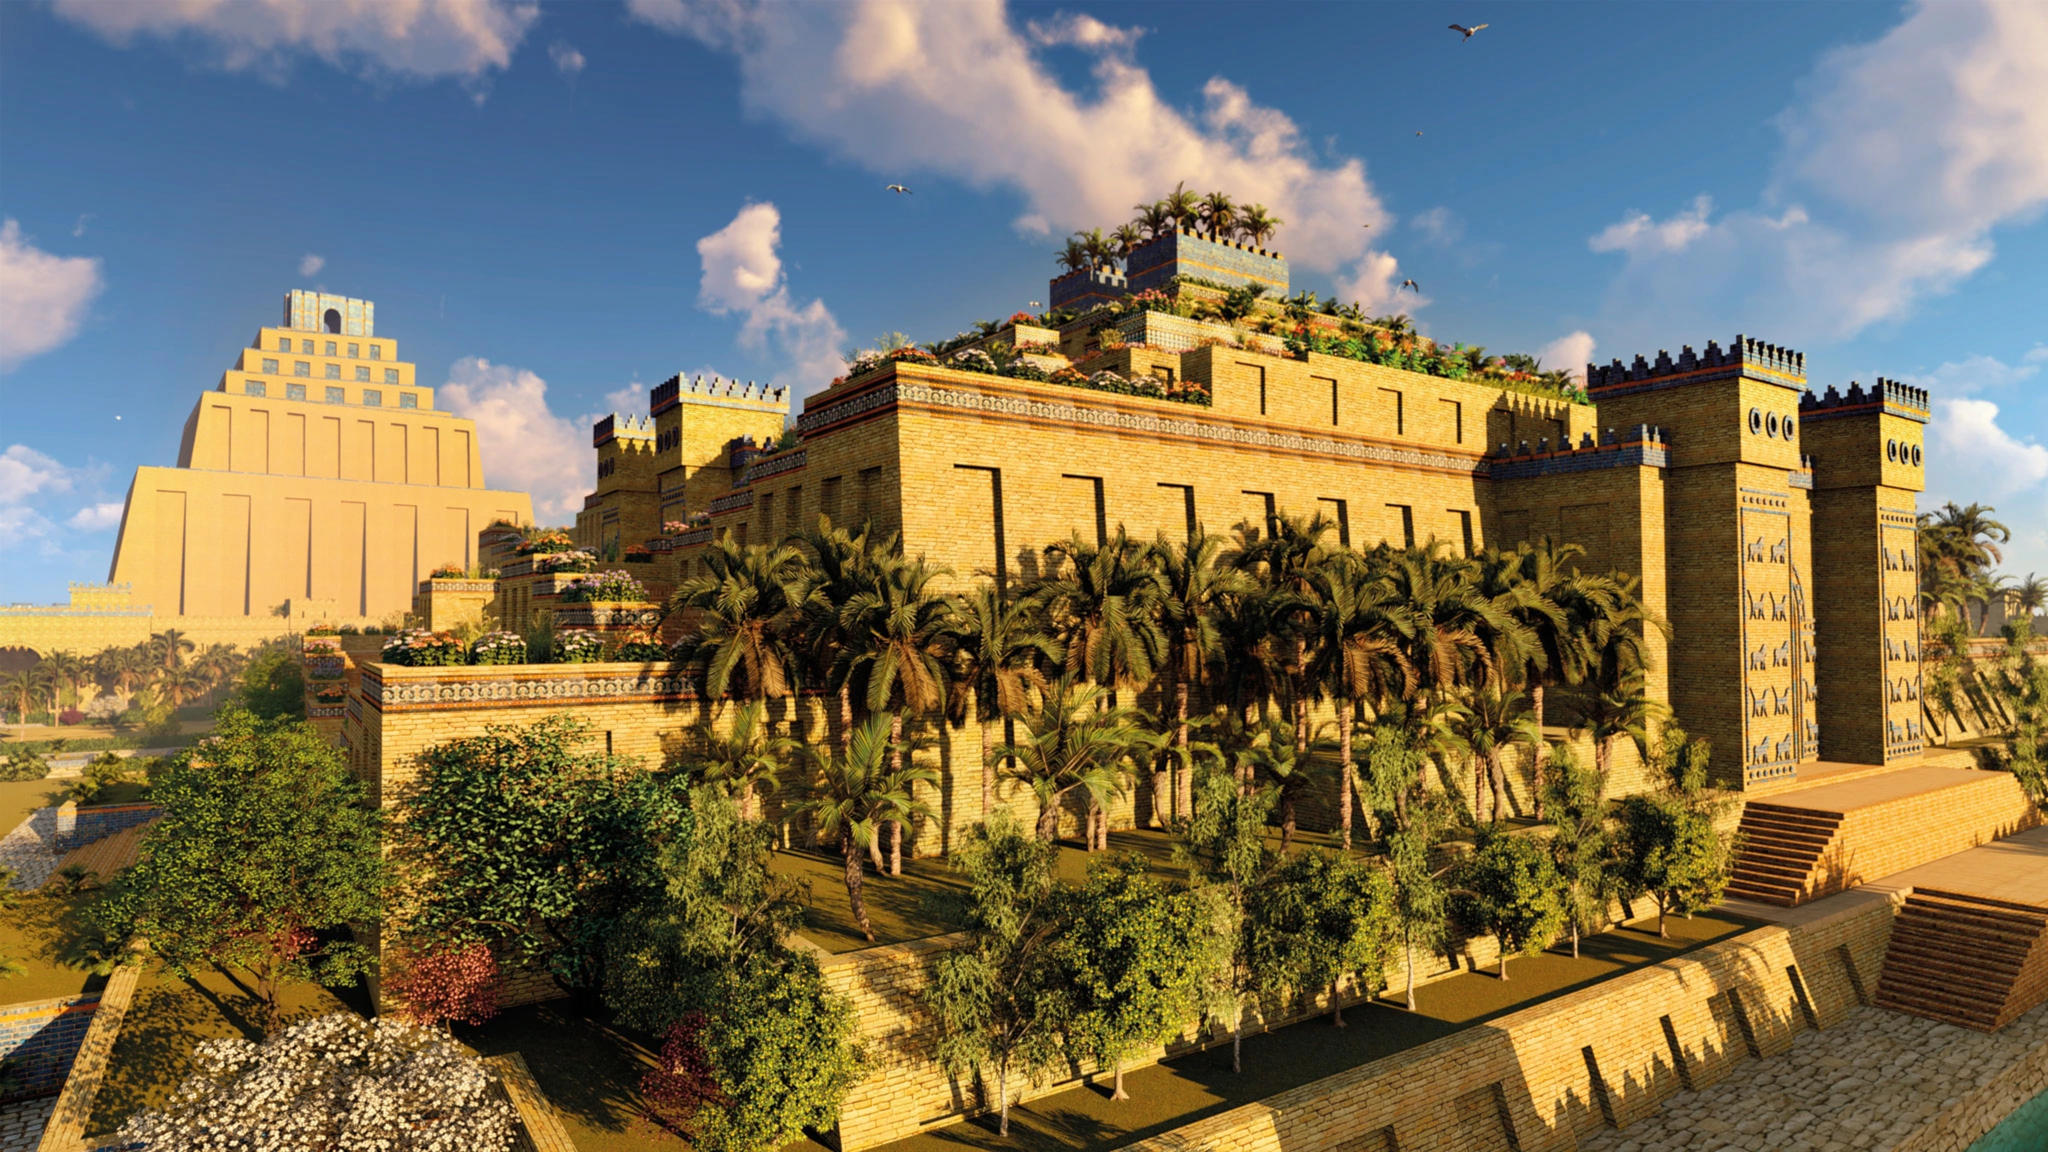Imagine being a traveler arriving in Babylon for the first time. How would you feel and what would you see? As a traveler arriving in Babylon for the first time, you would be struck with awe and wonder. The grand city walls loom majestically, seeming to touch the sky. Entering through one of the grand gates, adorned with mythical creatures, you are immediately immersed in the vibrancy of the city. The air is filled with the aroma of exotic spices and the sounds of bustling markets. The sight of the towering ziggurats and the lush Hanging Gardens is breathtaking, with greenery cascading down their terraces. The streets are thrumming with life, with merchants, nobles, and commoners alike moving in a harmonious dance of daily life. The sheer scale and beauty of Babylon would leave an indelible impression, marking it forever in your memory as a marvel of human achievement. Do you think there could be any hidden stories in the reliefs on the city walls? Absolutely! The reliefs on the city walls of Babylon likely hold a myriad of hidden stories. Each carving could depict significant historical events, capturing the triumphs and tribulations of Babylonian rulers and their people. Some reliefs might narrate mythological tales, immortalizing the gods and heroes revered by the Babylonians. Others could be visual records of daily life, trade, and craftsmanship, providing insights into the socio-economic fabric of the time. These intricate carvings serve not only as art but as a storytelling medium, preserving the legacy and culture of ancient Babylon for posterity. 